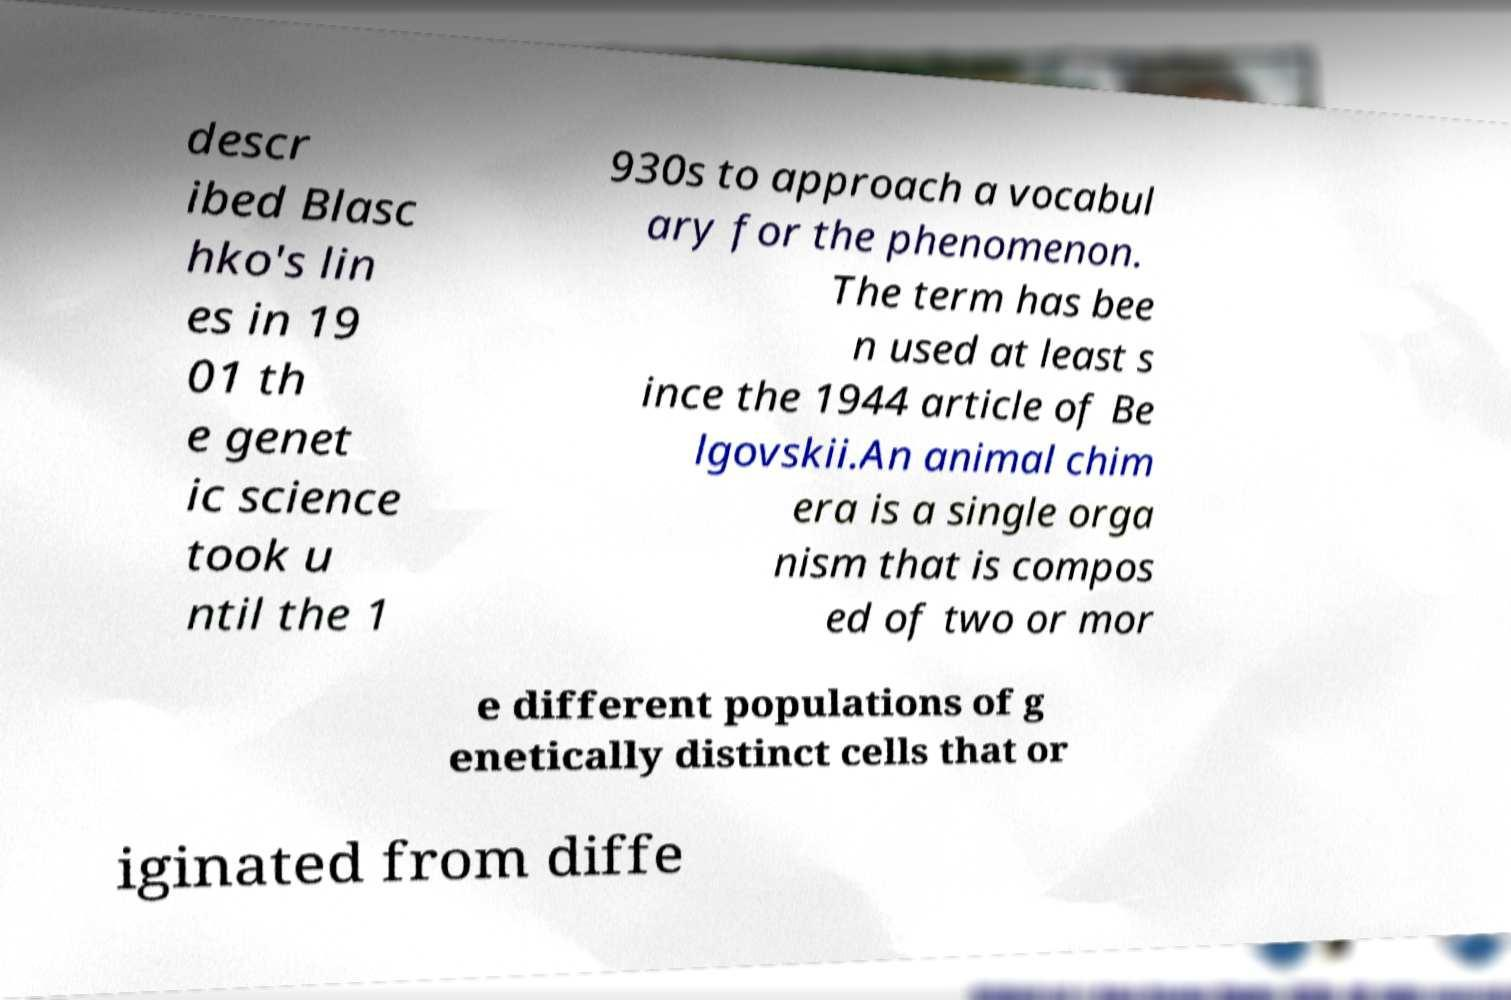Could you assist in decoding the text presented in this image and type it out clearly? descr ibed Blasc hko's lin es in 19 01 th e genet ic science took u ntil the 1 930s to approach a vocabul ary for the phenomenon. The term has bee n used at least s ince the 1944 article of Be lgovskii.An animal chim era is a single orga nism that is compos ed of two or mor e different populations of g enetically distinct cells that or iginated from diffe 